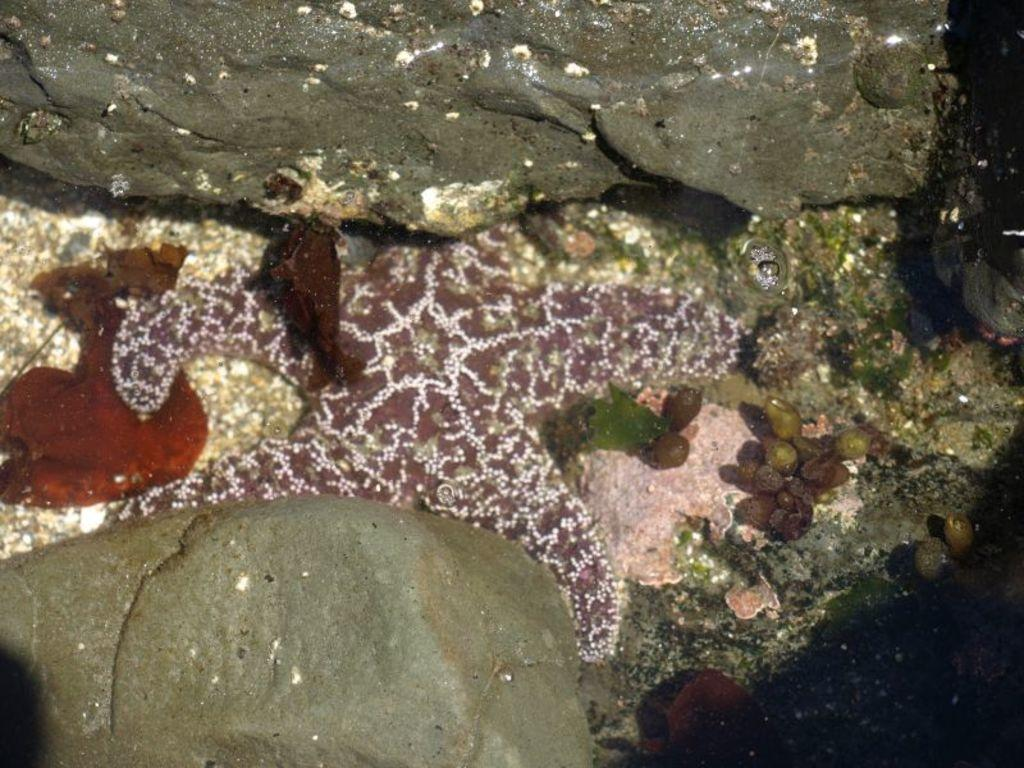What type of marine animal is in the water in the image? There is a starfish in the water in the image. What else can be seen in the image besides the starfish? There are rocks visible in the image. What type of sound does the starfish make in the image? Starfish do not make sounds, so there is no sound associated with the starfish in the image. 